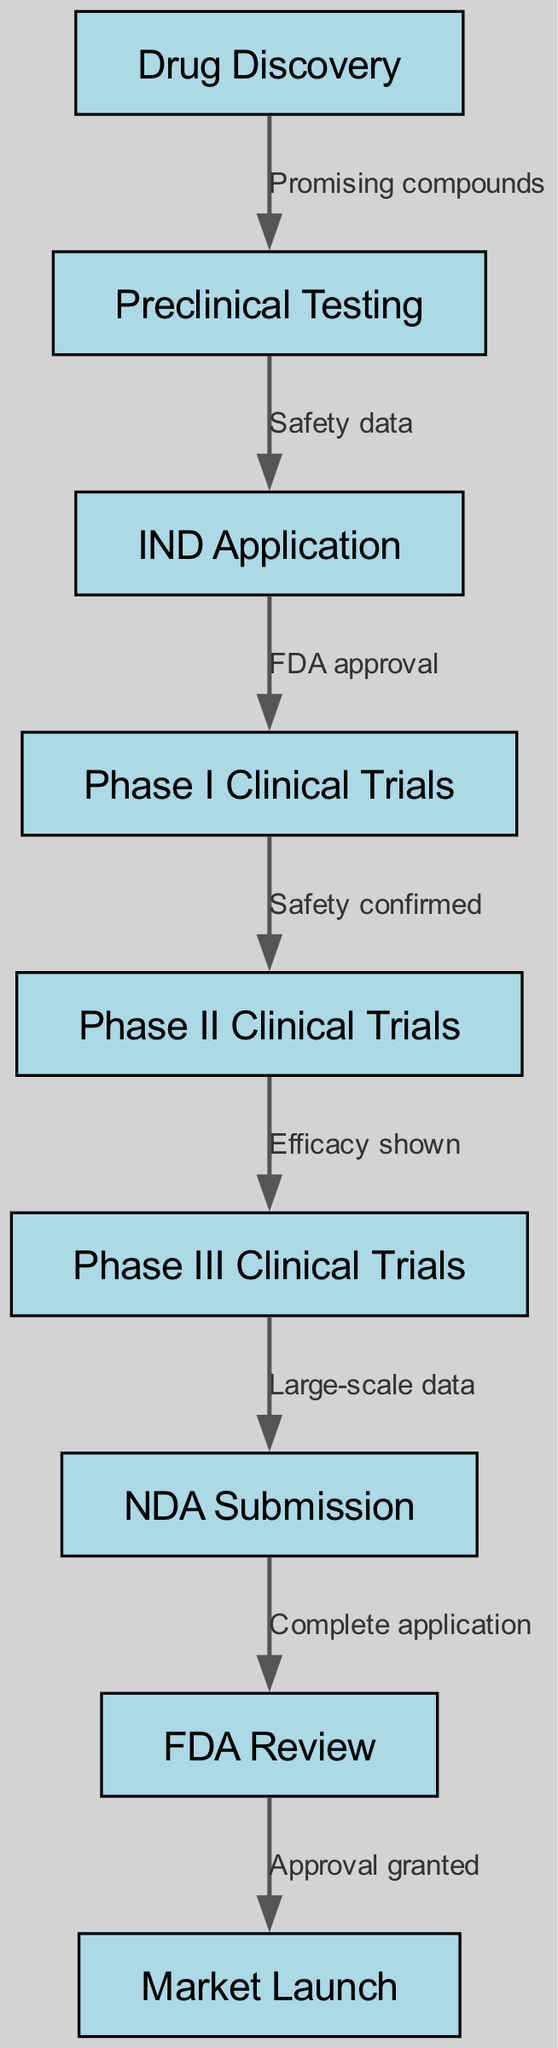What is the first step in the drug development process? The diagram starts with the node labeled "Drug Discovery," which represents the initiation of the drug development process.
Answer: Drug Discovery How many phases are there in clinical trials? In the diagram, there are three distinct phases of clinical trials listed as Phase I, Phase II, and Phase III. By counting these nodes, we see there are three phases.
Answer: 3 What is the outcome after preclinical testing? The edge leading from "Preclinical Testing" to "IND Application" is labeled "Safety data," indicating that after preclinical testing, safety data is generated.
Answer: Safety data What is required for Phase I Clinical Trials to proceed? The connection from the IND Application to Phase I Clinical Trials is labeled "FDA approval," which indicates that FDA approval is necessary for moving on to Phase I Clinical Trials.
Answer: FDA approval What is the connection between Phase II and Phase III Clinical Trials? The arrow from Phase II Clinical Trials to Phase III Clinical Trials is labeled "Efficacy shown," meaning the efficacy of the drug must be demonstrated in Phase II for it to proceed to Phase III.
Answer: Efficacy shown What happens after the NDA Submission? The diagram shows an edge from the NDA Submission to FDA Review, which is labeled "Complete application," indicating that a complete application is needed to move to the FDA review stage.
Answer: Complete application What does FDA Review lead to? The edge from FDA Review to Market Launch is labeled "Approval granted," signifying that once the FDA review is completed successfully, approval is granted, leading to the market launch.
Answer: Approval granted Which step follows large-scale data collection? The flowchart indicates that Phase III Clinical Trials are the step that follows the collection of large-scale data, linking these two nodes in the process.
Answer: Phase III Clinical Trials What kind of compounds are informed by the Drug Discovery stage? The edge from Drug Discovery to Preclinical Testing indicates that ‘Promising compounds’ are the result of this initial step, defining what is taken for preclinical testing.
Answer: Promising compounds 